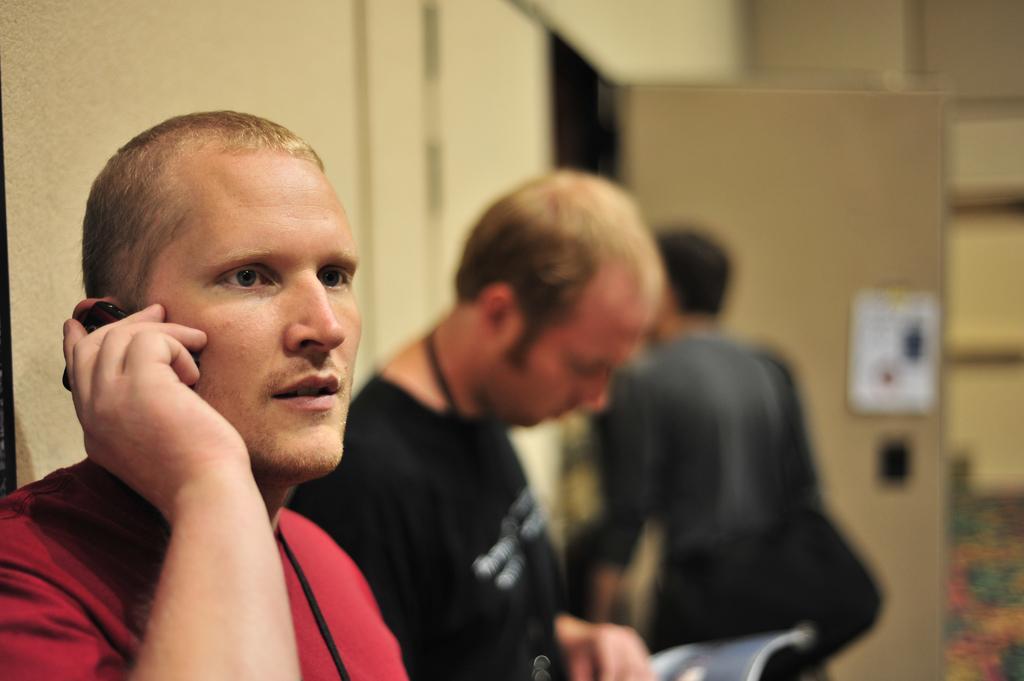Please provide a concise description of this image. In this image there are people standing. To the left side of the image there is wall. There is a door. 